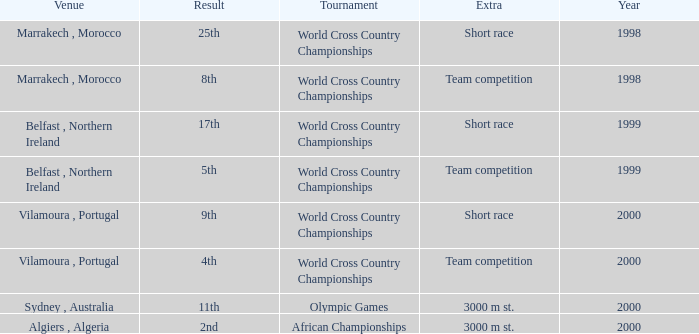Tell me the sum of year for 5th result 1999.0. 